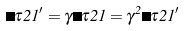<formula> <loc_0><loc_0><loc_500><loc_500>\Delta \tau 2 1 ^ { \prime } = \gamma \Delta \tau 2 1 = \gamma ^ { 2 } \Delta \tau 2 1 ^ { \prime }</formula> 